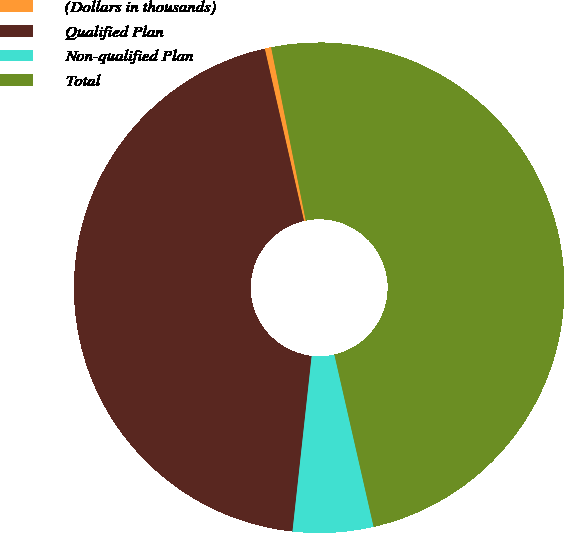Convert chart. <chart><loc_0><loc_0><loc_500><loc_500><pie_chart><fcel>(Dollars in thousands)<fcel>Qualified Plan<fcel>Non-qualified Plan<fcel>Total<nl><fcel>0.43%<fcel>44.7%<fcel>5.3%<fcel>49.57%<nl></chart> 